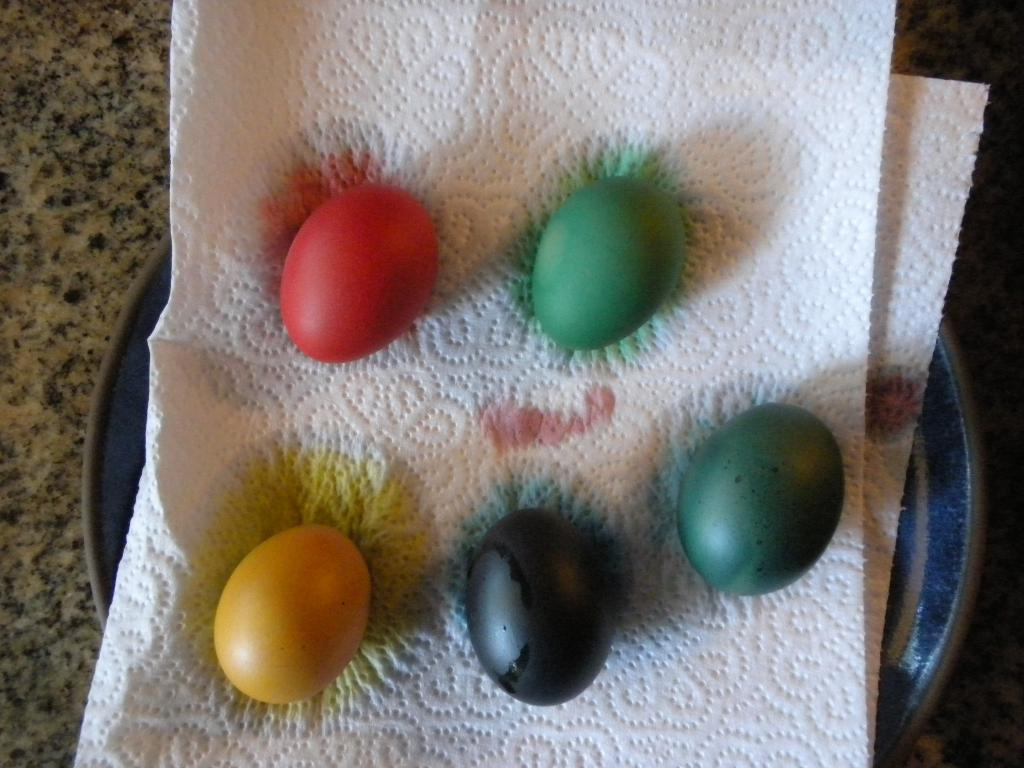How many eggs are visible in the image? There are five eggs in the image. What distinguishes the eggs from one another? The eggs are of different colors. What is the eggs resting on in the image? The eggs are on a paper towel. What is the eggs contained within in the image? The eggs are in a plate. Where might the image have been taken? The image is likely taken in a room, as there is no indication of an outdoor setting. Can you see a flock of birds flying in the image? No, there are no birds or flocks visible in the image; it features five eggs in a plate. 